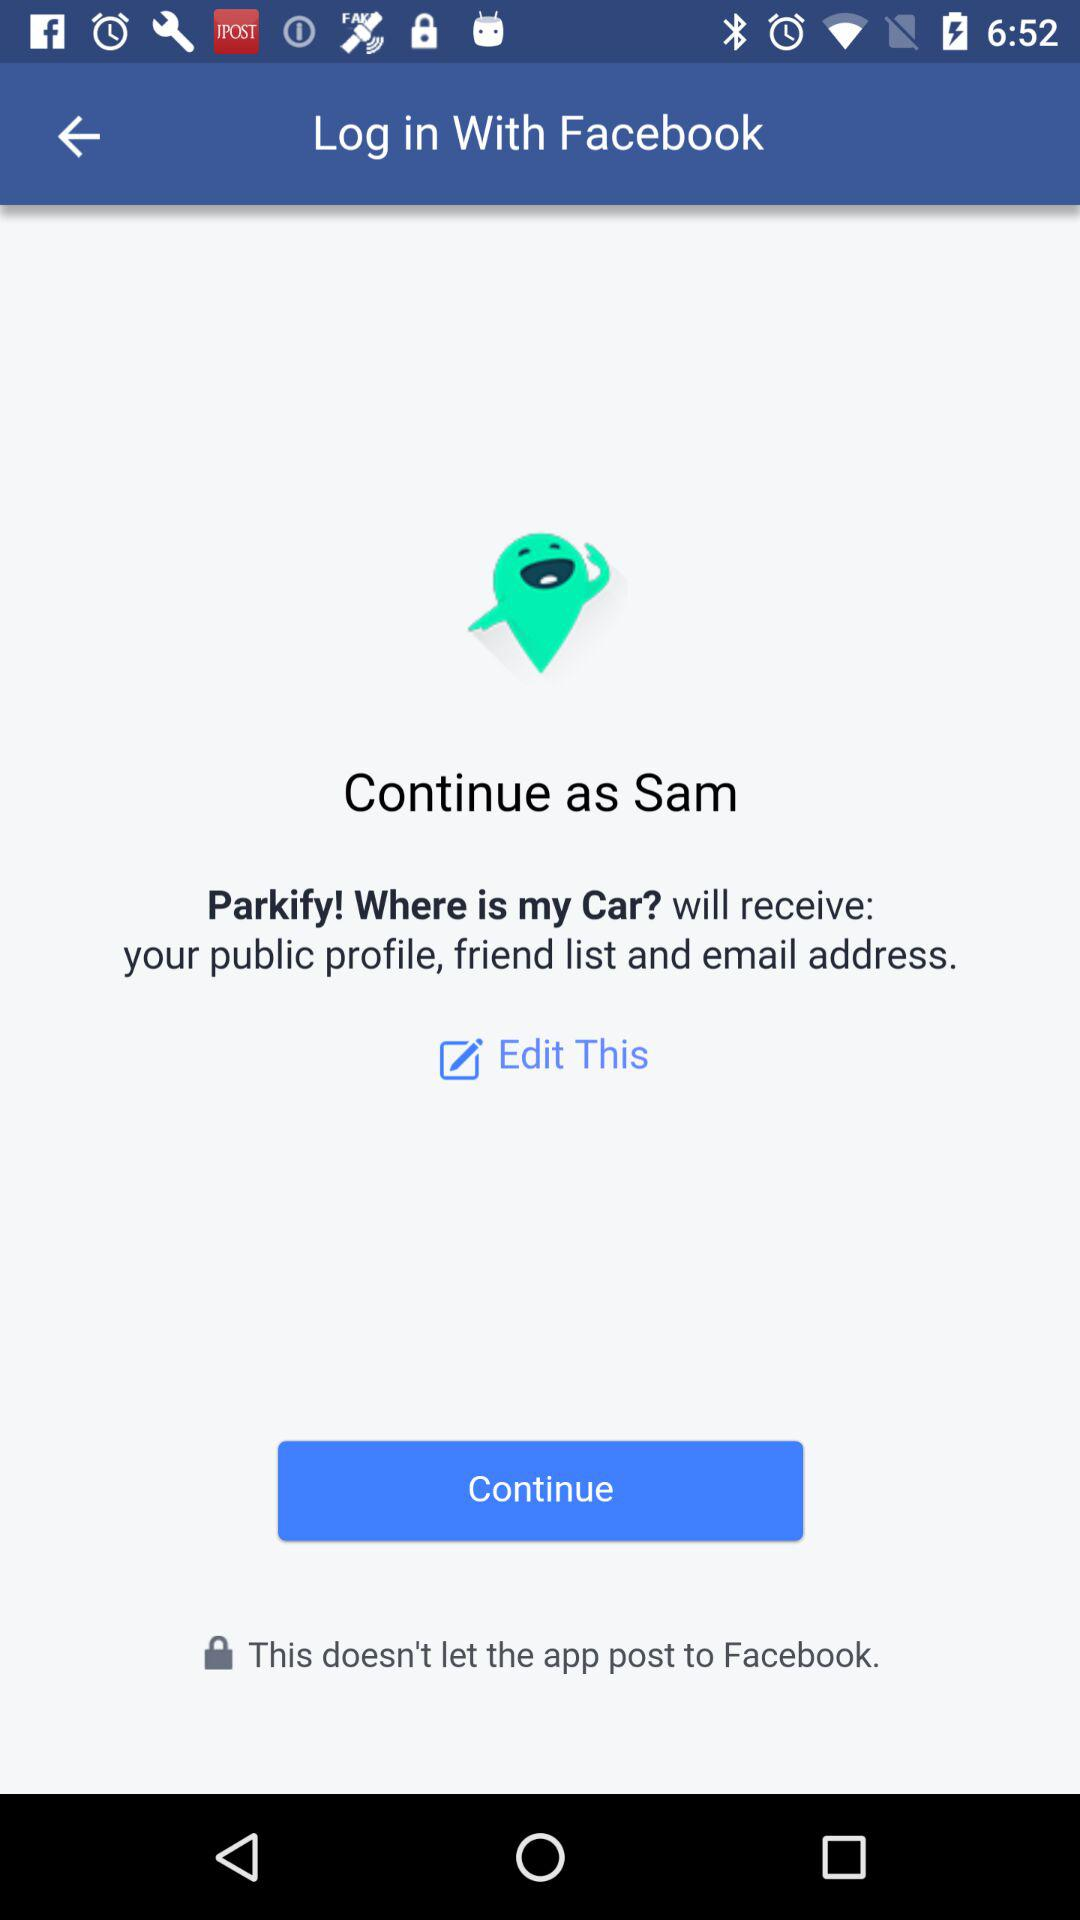What is the name of the user? The name of the user is Sam. 